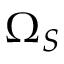<formula> <loc_0><loc_0><loc_500><loc_500>\Omega _ { S }</formula> 